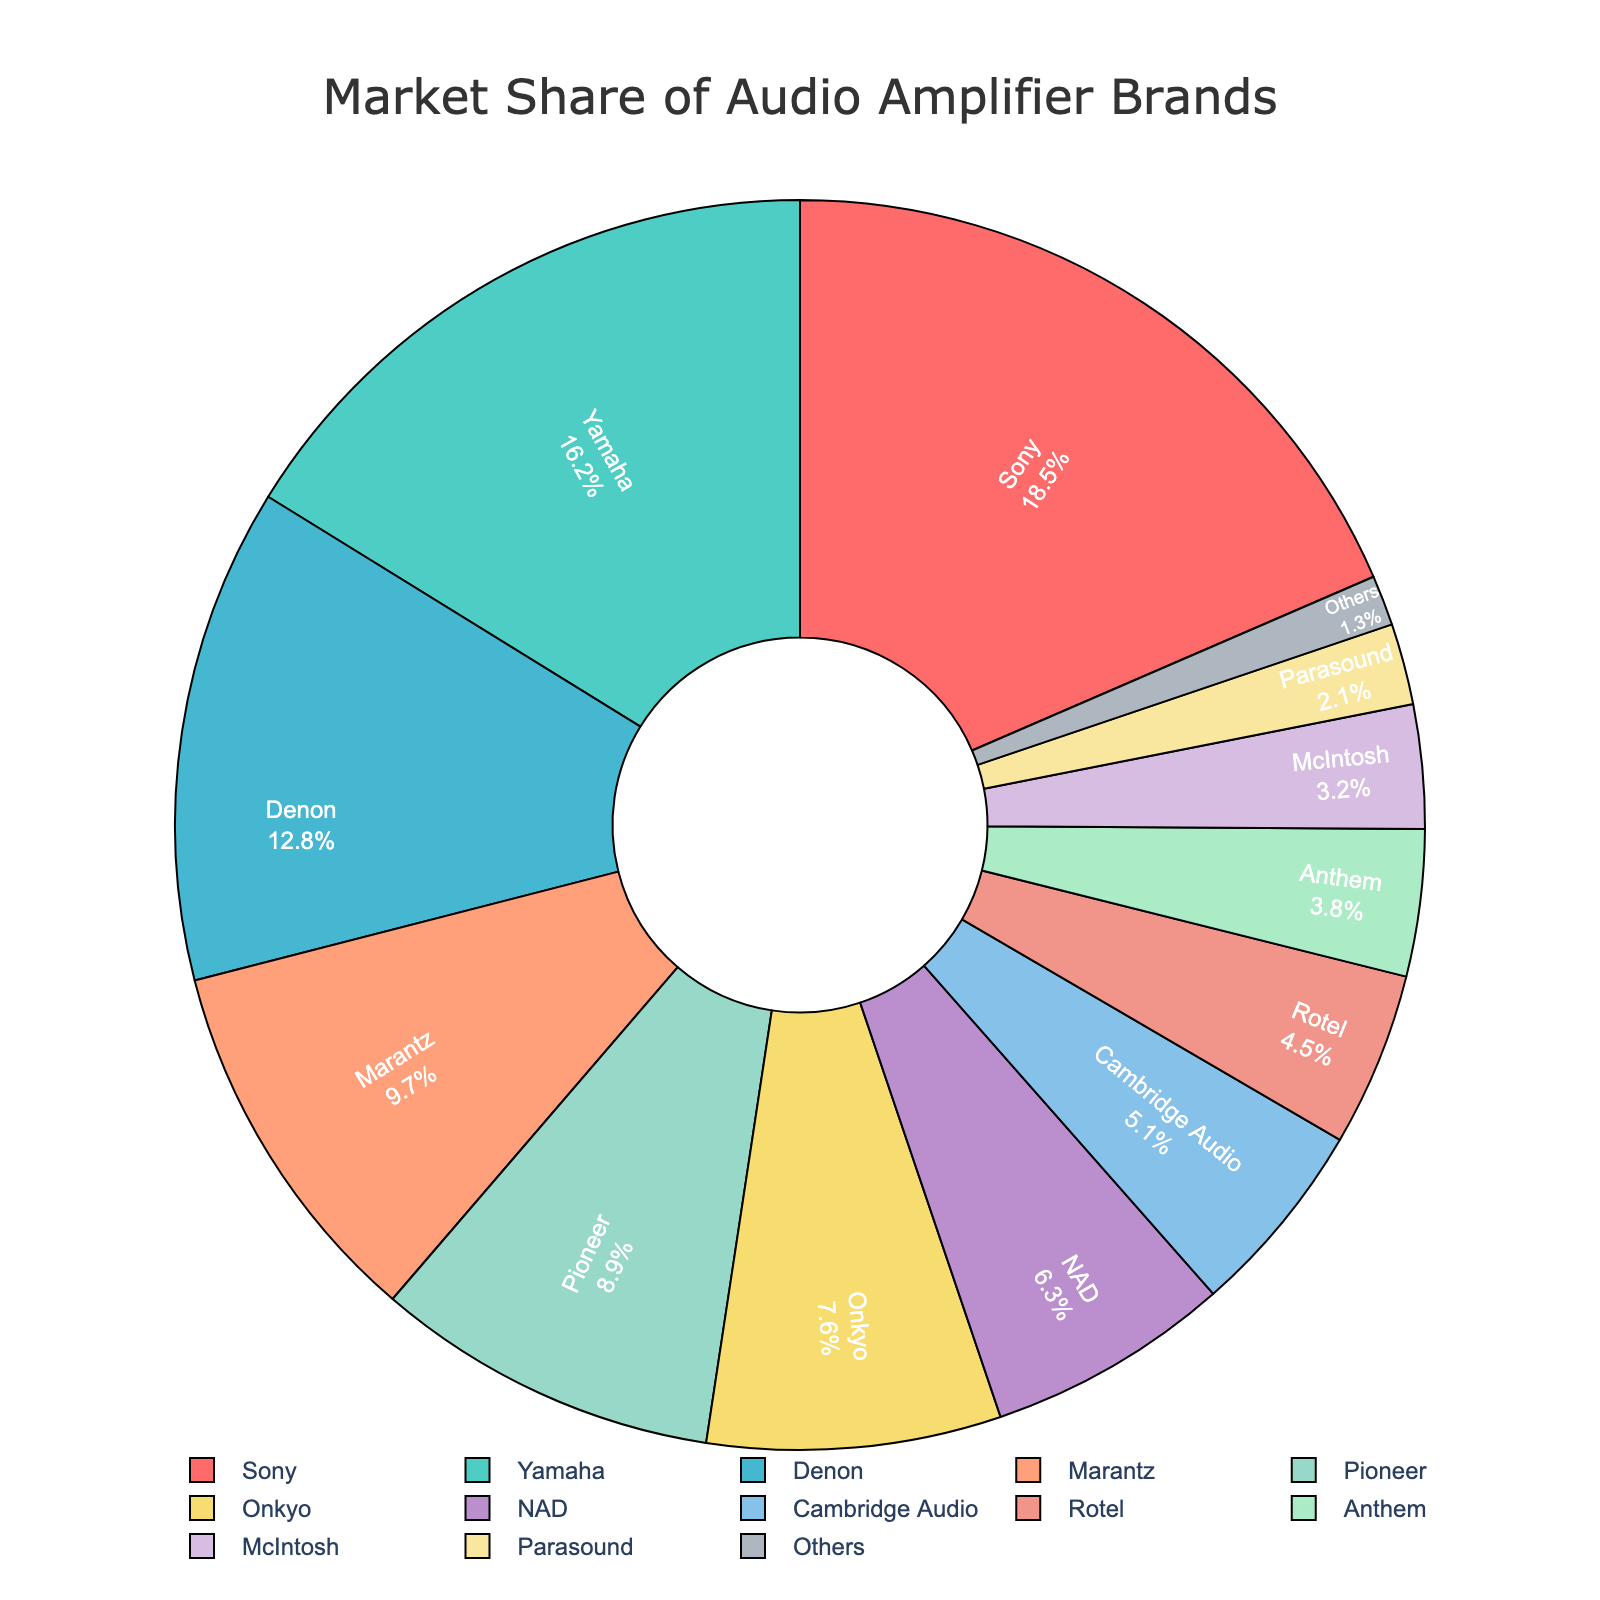Which brand has the highest market share? By looking at the pie chart, the segment with the largest area represents the brand with the highest market share. In this case, Sony has the largest segment.
Answer: Sony Which brand has the smallest market share? The smallest segment in the pie chart represents the brand with the smallest market share. The "Others" category has the smallest share.
Answer: Others What is the combined market share of Sony and Yamaha? The market share of Sony is 18.5%, and Yamaha is 16.2%. Adding these two together, the combined market share is 18.5% + 16.2%.
Answer: 34.7% How does the market share of Denon compare to Marantz? Denon has a market share of 12.8%, and Marantz has a market share of 9.7%. By comparing these two values, we see that Denon's market share is larger.
Answer: Denon What is the difference in market share between Sony and Onkyo? Sony has a market share of 18.5%, and Onkyo has a market share of 7.6%. Subtracting Onkyo's share from Sony's share gives 18.5% - 7.6%.
Answer: 10.9% What is the average market share of Pioneer, NAD, and Cambridge Audio? To find the average market share, add the market shares of Pioneer (8.9%), NAD (6.3%), and Cambridge Audio (5.1%) together and then divide by 3. (8.9% + 6.3% + 5.1%) / 3 = 20.3% / 3.
Answer: 6.77% Which brands have a market share greater than 10%? The pie chart shows that Sony, Yamaha, and Denon have segments representing more than 10% market share each.
Answer: Sony, Yamaha, Denon How much more market share does Marantz have compared to McIntosh? Marantz has a market share of 9.7%, and McIntosh has 3.2%. The difference is calculated by 9.7% - 3.2%.
Answer: 6.5% What is the total market share of the brands listed excluding "Others"? Adding up the market shares of all brands except "Others" involves summing the following: Sony (18.5%), Yamaha (16.2%), Denon (12.8%), Marantz (9.7%), Pioneer (8.9%), Onkyo (7.6%), NAD (6.3%), Cambridge Audio (5.1%), Rotel (4.5%), Anthem (3.8%), McIntosh (3.2%), Parasound (2.1%). The total is 18.5% + 16.2% + 12.8% + 9.7% + 8.9% + 7.6% + 6.3% + 5.1% + 4.5% + 3.8% + 3.2% + 2.1%.
Answer: 99.7% 